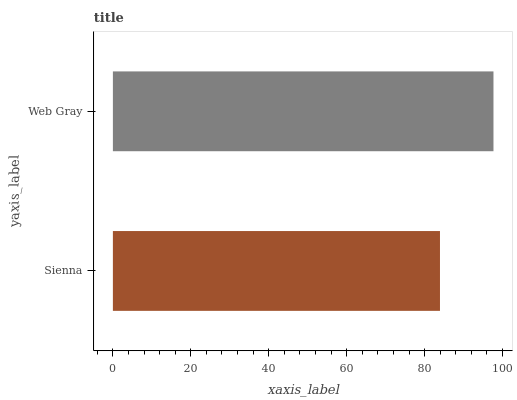Is Sienna the minimum?
Answer yes or no. Yes. Is Web Gray the maximum?
Answer yes or no. Yes. Is Web Gray the minimum?
Answer yes or no. No. Is Web Gray greater than Sienna?
Answer yes or no. Yes. Is Sienna less than Web Gray?
Answer yes or no. Yes. Is Sienna greater than Web Gray?
Answer yes or no. No. Is Web Gray less than Sienna?
Answer yes or no. No. Is Web Gray the high median?
Answer yes or no. Yes. Is Sienna the low median?
Answer yes or no. Yes. Is Sienna the high median?
Answer yes or no. No. Is Web Gray the low median?
Answer yes or no. No. 